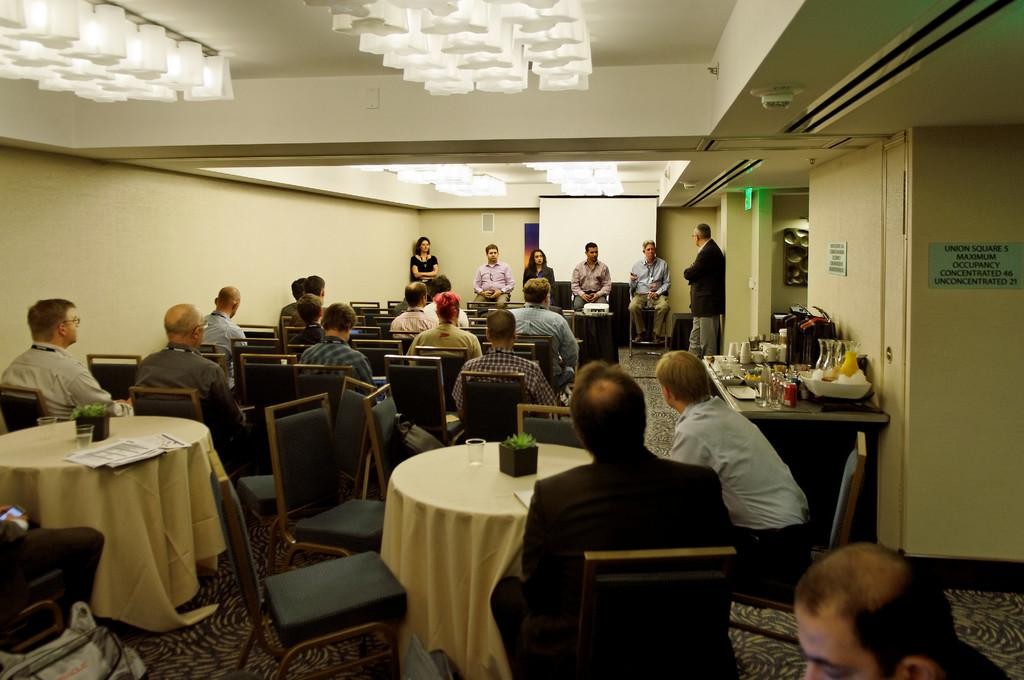What are the people in the image doing? The people in the image are sitting on chairs. Is there anyone standing in the image? Yes, there is a man standing in the image. What objects can be seen on the table in the image? There are cups and glasses on the table in the image. What type of pet is visible in the image? There are no pets present in the image. How does the man express his anger in the image? The man does not express anger in the image; he is simply standing. 